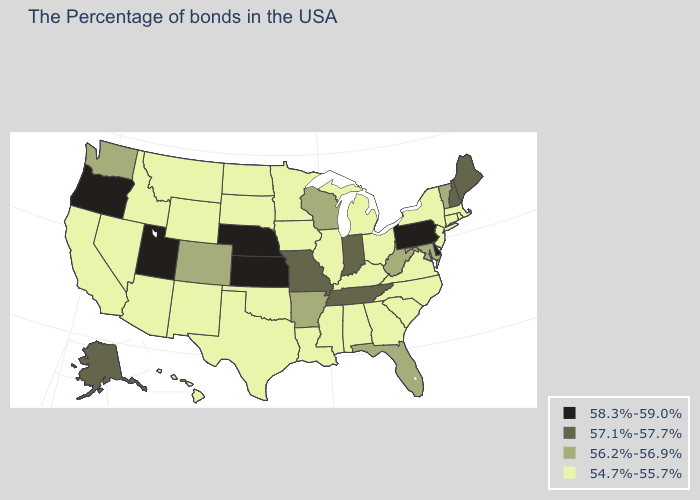Does the first symbol in the legend represent the smallest category?
Give a very brief answer. No. What is the value of Alaska?
Be succinct. 57.1%-57.7%. Which states have the highest value in the USA?
Quick response, please. Delaware, Pennsylvania, Kansas, Nebraska, Utah, Oregon. Which states have the highest value in the USA?
Give a very brief answer. Delaware, Pennsylvania, Kansas, Nebraska, Utah, Oregon. Does the map have missing data?
Write a very short answer. No. Among the states that border Oregon , does California have the lowest value?
Write a very short answer. Yes. What is the value of West Virginia?
Quick response, please. 56.2%-56.9%. Among the states that border Washington , does Idaho have the lowest value?
Give a very brief answer. Yes. What is the value of Oklahoma?
Quick response, please. 54.7%-55.7%. What is the value of Wyoming?
Give a very brief answer. 54.7%-55.7%. Name the states that have a value in the range 54.7%-55.7%?
Quick response, please. Massachusetts, Rhode Island, Connecticut, New York, New Jersey, Virginia, North Carolina, South Carolina, Ohio, Georgia, Michigan, Kentucky, Alabama, Illinois, Mississippi, Louisiana, Minnesota, Iowa, Oklahoma, Texas, South Dakota, North Dakota, Wyoming, New Mexico, Montana, Arizona, Idaho, Nevada, California, Hawaii. What is the lowest value in the South?
Answer briefly. 54.7%-55.7%. What is the value of Kansas?
Concise answer only. 58.3%-59.0%. What is the value of Georgia?
Quick response, please. 54.7%-55.7%. What is the value of Florida?
Concise answer only. 56.2%-56.9%. 